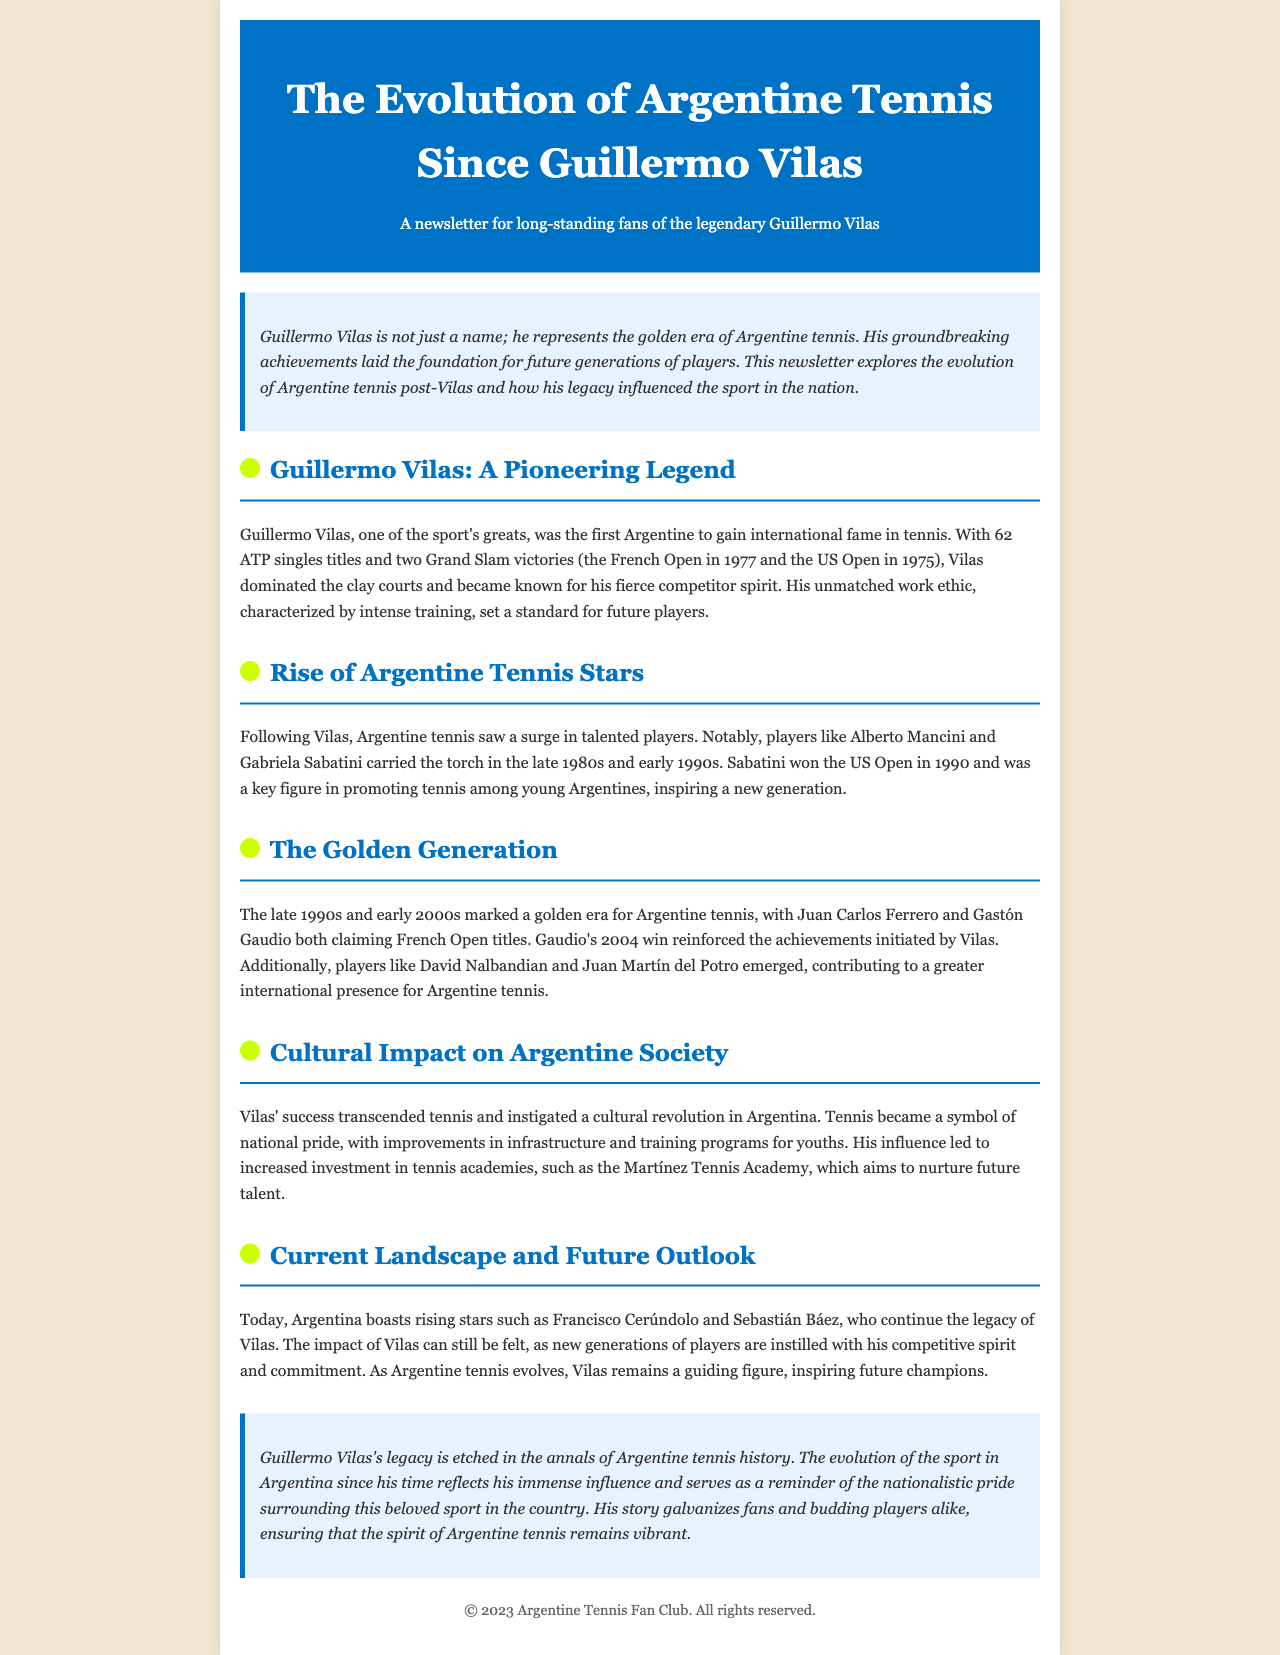What year did Guillermo Vilas win the French Open? The document states that Vilas won the French Open in 1977.
Answer: 1977 Who is mentioned as carrying the torch after Vilas? The document notes Alberto Mancini and Gabriela Sabatini as players who followed Vilas's lead.
Answer: Alberto Mancini and Gabriela Sabatini Which title did Gabriela Sabatini win? The document indicates that Sabatini won the US Open in 1990.
Answer: US Open What major tournament did Gaudio win? The newsletter mentions that Gastón Gaudio won the French Open in 2004.
Answer: French Open What is the name of the tennis academy mentioned? The document refers to the Martínez Tennis Academy as a place for nurturing future talent.
Answer: Martínez Tennis Academy How many ATP singles titles did Guillermo Vilas win? The document states that Vilas won 62 ATP singles titles during his career.
Answer: 62 Which Argentine players are noted as rising stars today? The document highlights Francisco Cerúndolo and Sebastián Báez as current rising stars.
Answer: Francisco Cerúndolo and Sebastián Báez What cultural effect did Vilas have on Argentine society? The newsletter explains that Vilas's success turned tennis into a symbol of national pride and improved infrastructure.
Answer: National pride What is the primary focus of the newsletter? The document's title indicates that the focus is on the evolution of Argentine tennis since Vilas and his influence.
Answer: Evolution of Argentine tennis since Vilas 